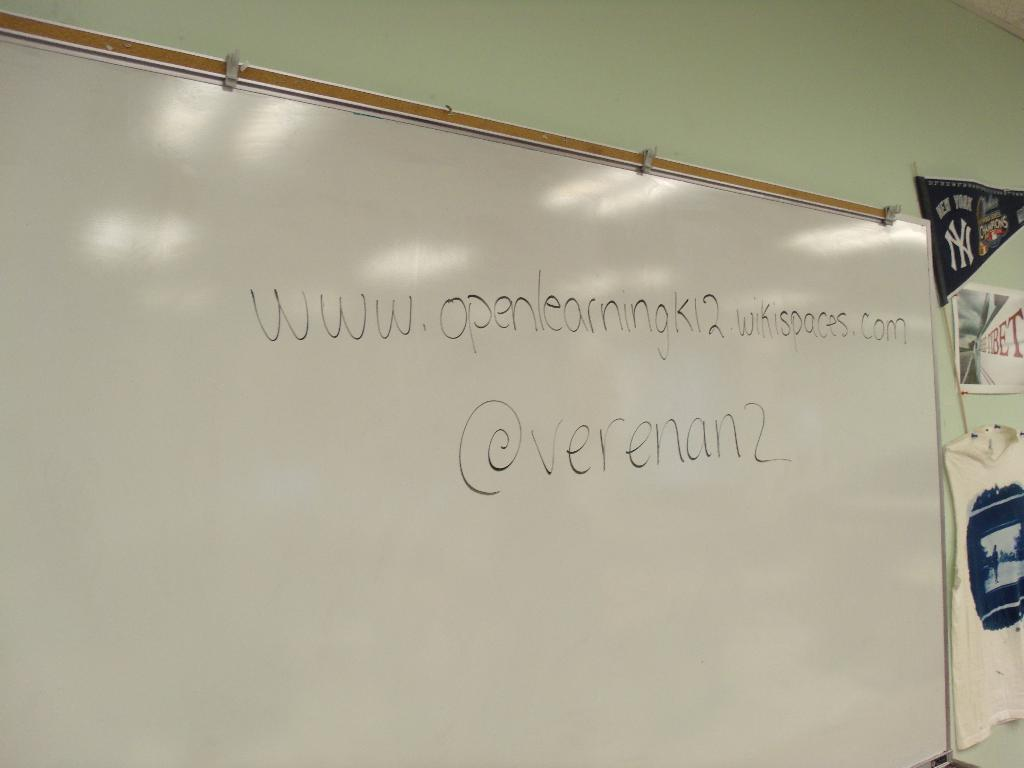<image>
Share a concise interpretation of the image provided. A web address is written on a white board next to a New York Yankees pennant. 